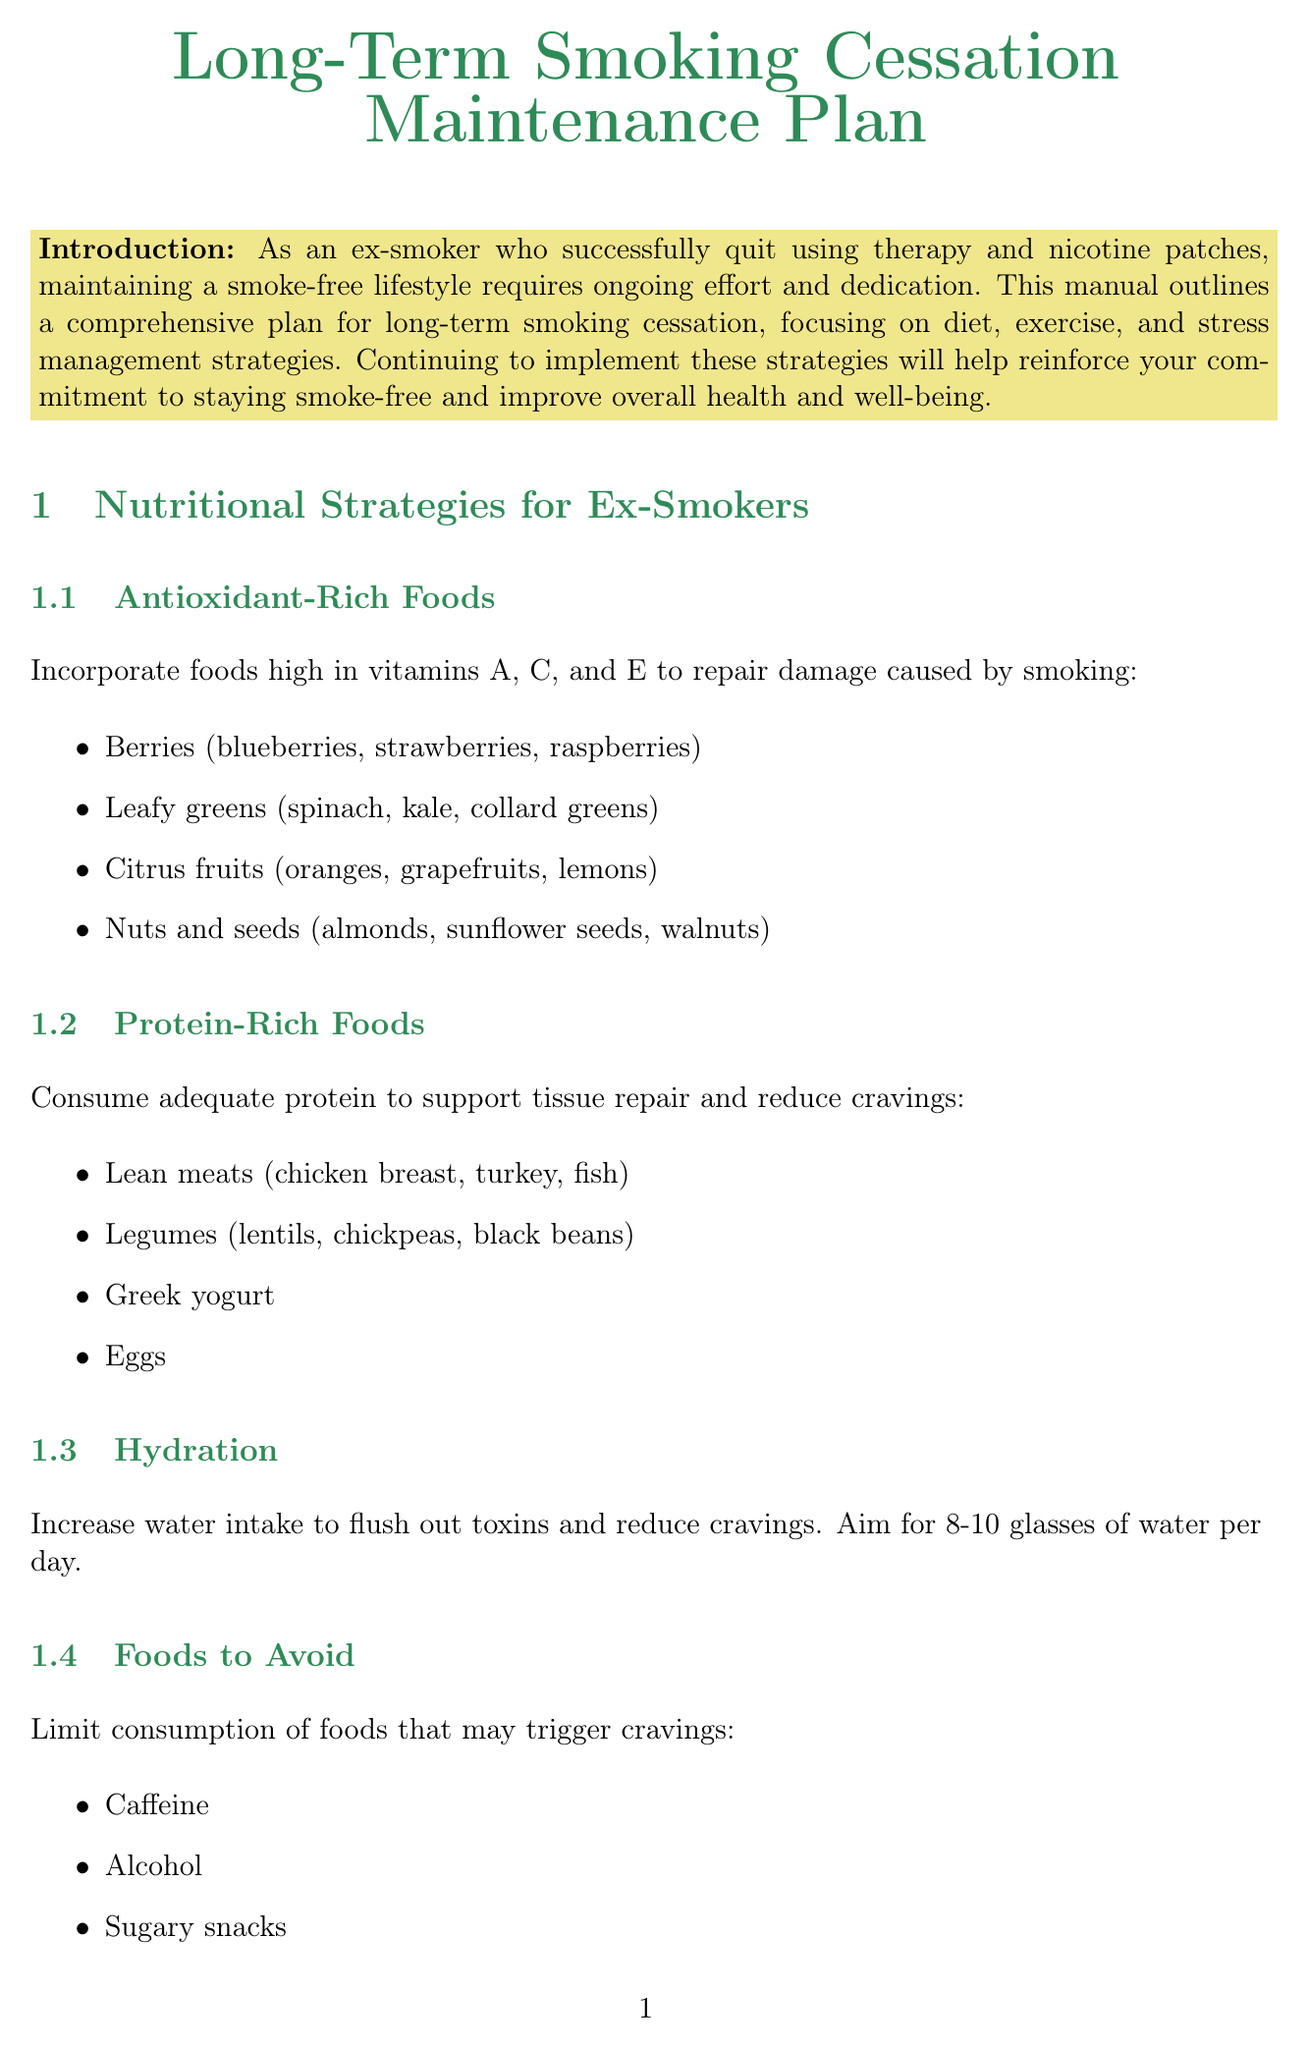What is the title of the manual? The title of the manual is stated at the beginning of the document.
Answer: Long-Term Smoking Cessation Maintenance Plan How many glasses of water should ex-smokers aim to drink daily? The document provides a specific recommendation for daily water intake.
Answer: 8-10 glasses What protein-rich food is mentioned in the document? The document lists examples of protein-rich foods.
Answer: Lean meats What frequency is suggested for practicing yoga? The document specifies the recommended frequency for yoga as part of the exercise regimen.
Answer: 2-3 days per week Name a mindfulness app suggested for meditation. The document mentions specific apps for mindfulness meditation.
Answer: Headspace How long should the deep breathing exercise technique be practiced? The document provides detailed instructions about the deep breathing technique and its duration.
Answer: 4-7-8 seconds What strategy is recommended for developing coping mechanisms? The document suggests a specific alternative activity for managing cravings.
Answer: Use nicotine replacement therapy What is one reason for maintaining social support? The document highlights the significance of social support in the maintenance of a smoke-free lifestyle.
Answer: Reduce cravings What should be celebrated as part of the reward system? The document states the importance of recognizing milestones to reinforce positive behavior.
Answer: Milestones 